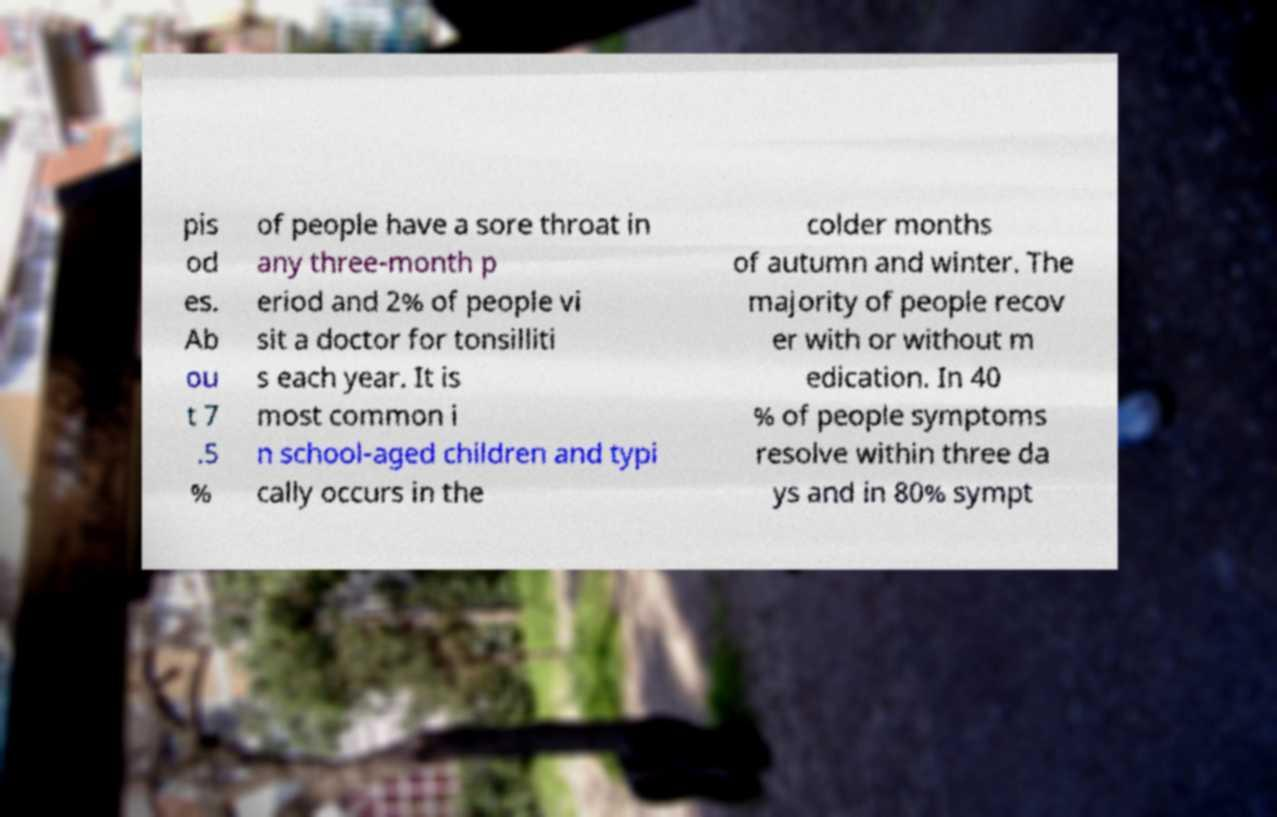There's text embedded in this image that I need extracted. Can you transcribe it verbatim? pis od es. Ab ou t 7 .5 % of people have a sore throat in any three-month p eriod and 2% of people vi sit a doctor for tonsilliti s each year. It is most common i n school-aged children and typi cally occurs in the colder months of autumn and winter. The majority of people recov er with or without m edication. In 40 % of people symptoms resolve within three da ys and in 80% sympt 